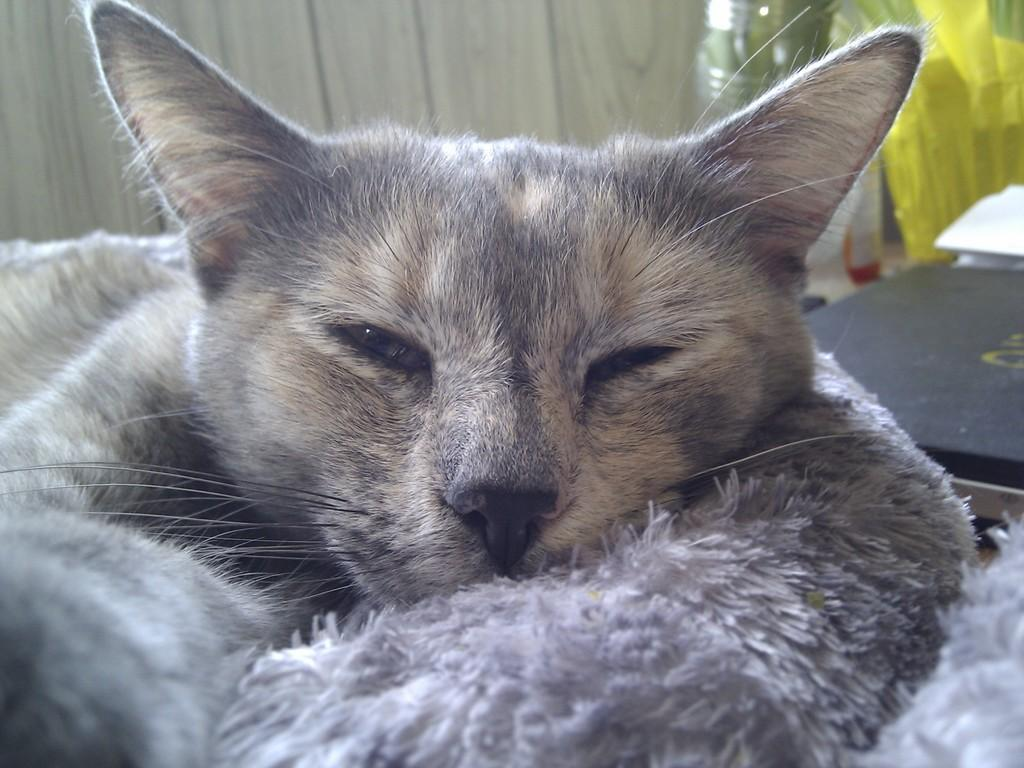What is the main subject in the center of the image? There is a cat in the center of the image. What can be seen in the background of the image? There is a bottle and some objects visible in the background. Can you describe the wall in the background of the image? There is a wooden wall in the background of the image. How many gold chairs can be seen in the image? There are no gold chairs present in the image. What type of test is the cat taking in the image? There is no test present in the image; it is a picture of a cat and other elements in the background. 